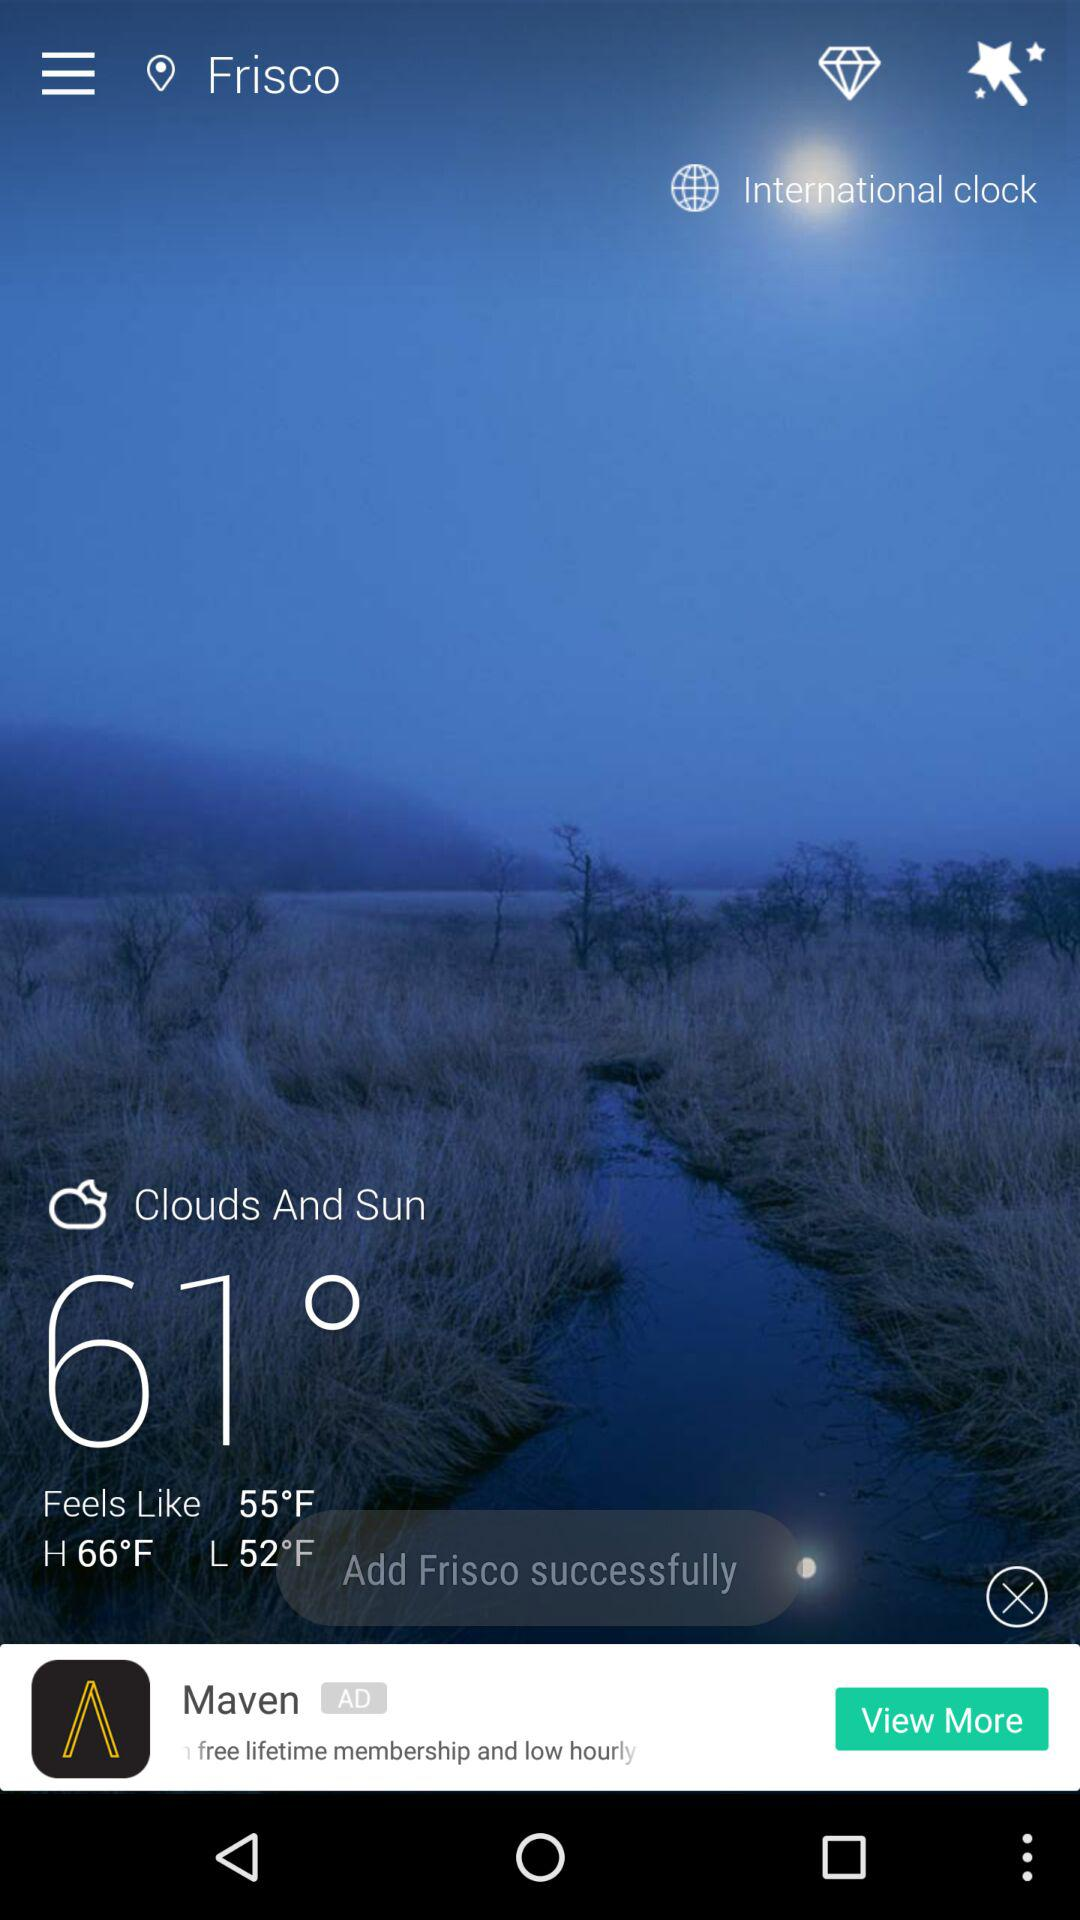What is the current location? The current location is Frisco. 